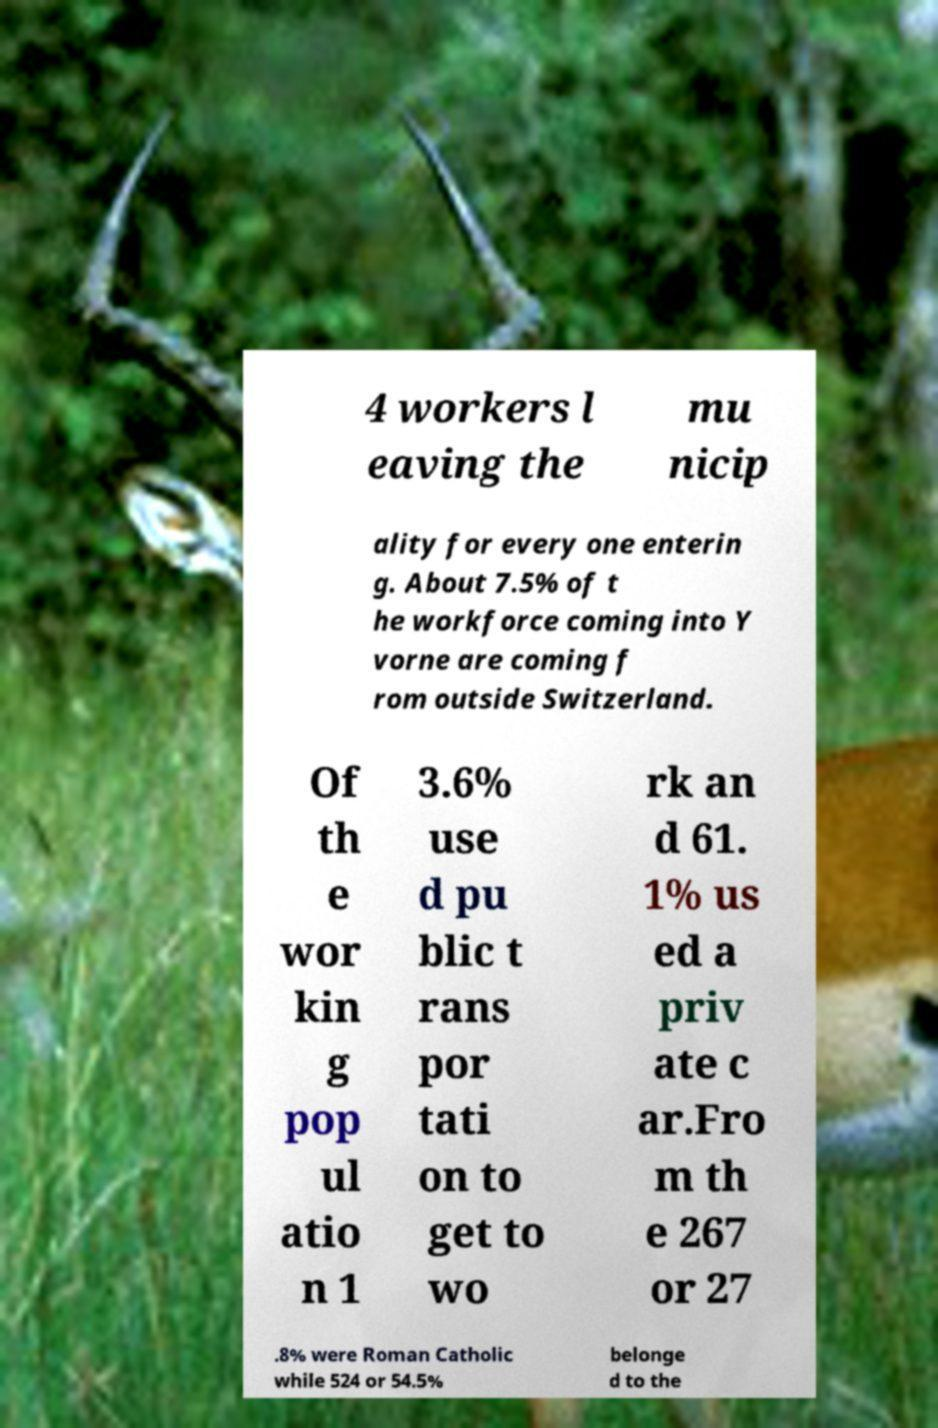Could you extract and type out the text from this image? 4 workers l eaving the mu nicip ality for every one enterin g. About 7.5% of t he workforce coming into Y vorne are coming f rom outside Switzerland. Of th e wor kin g pop ul atio n 1 3.6% use d pu blic t rans por tati on to get to wo rk an d 61. 1% us ed a priv ate c ar.Fro m th e 267 or 27 .8% were Roman Catholic while 524 or 54.5% belonge d to the 